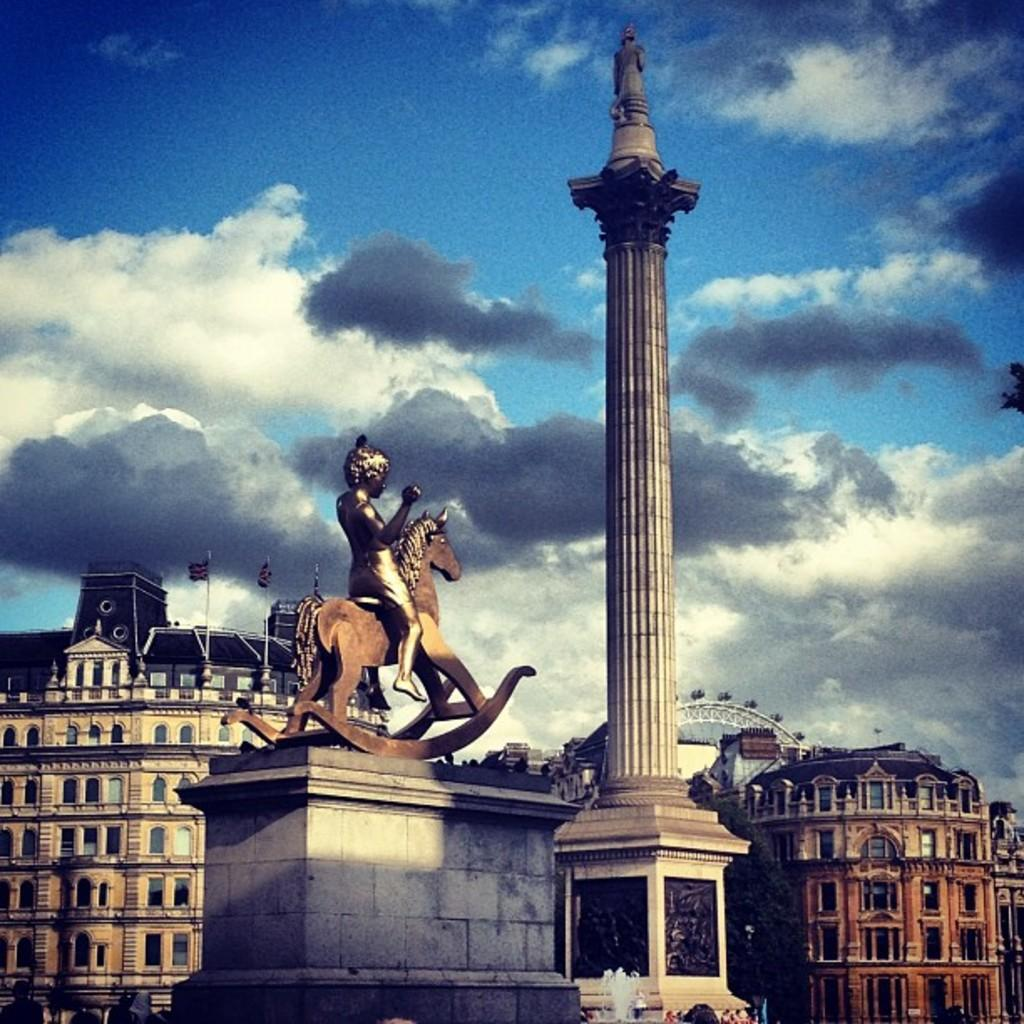What is the main subject in the image? There is a statue in the image. What type of structures can be seen in the image? There are buildings with windows in the image. What additional features are present in the image? There are flags, a fountain, a roller coaster, and a tower in the image. What can be seen in the sky in the image? The sky is visible in the image, and it appears cloudy. How does the statue behave in the image? The statue does not behave in the image, as it is an inanimate object. Can you find a drawer in the image? There is no drawer present in the image. 